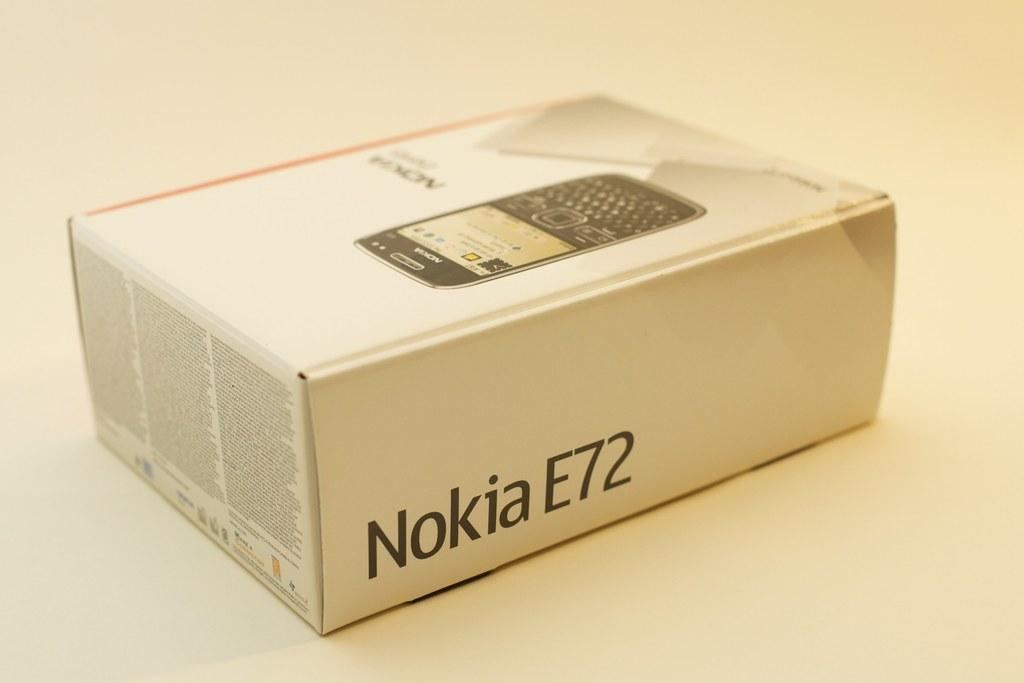<image>
Give a short and clear explanation of the subsequent image. A white box for a Nokia E72 cell phone. 